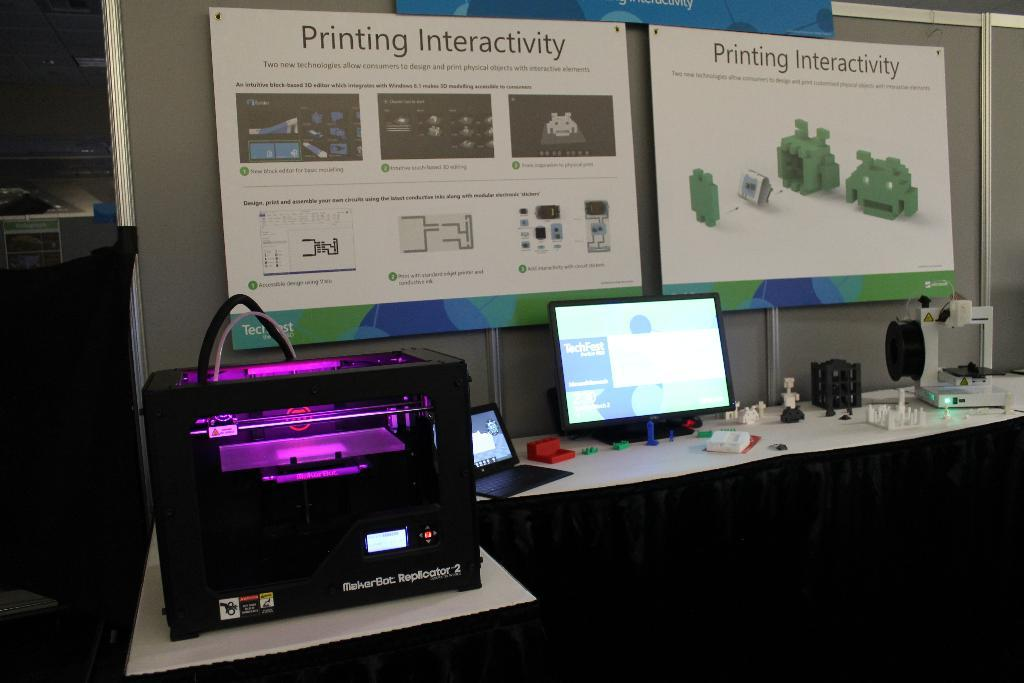<image>
Summarize the visual content of the image. A sign board shows a interactive printer display. 